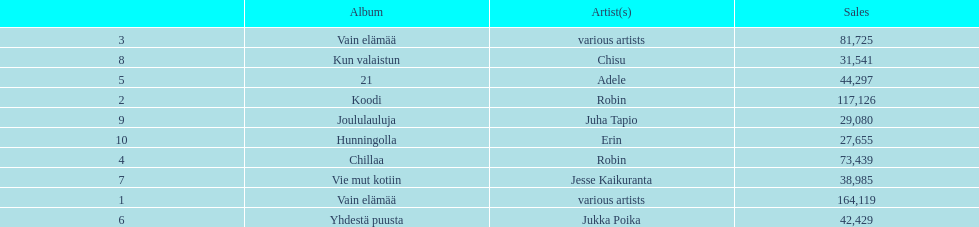Which was the last album to sell over 100,000 records? Koodi. 